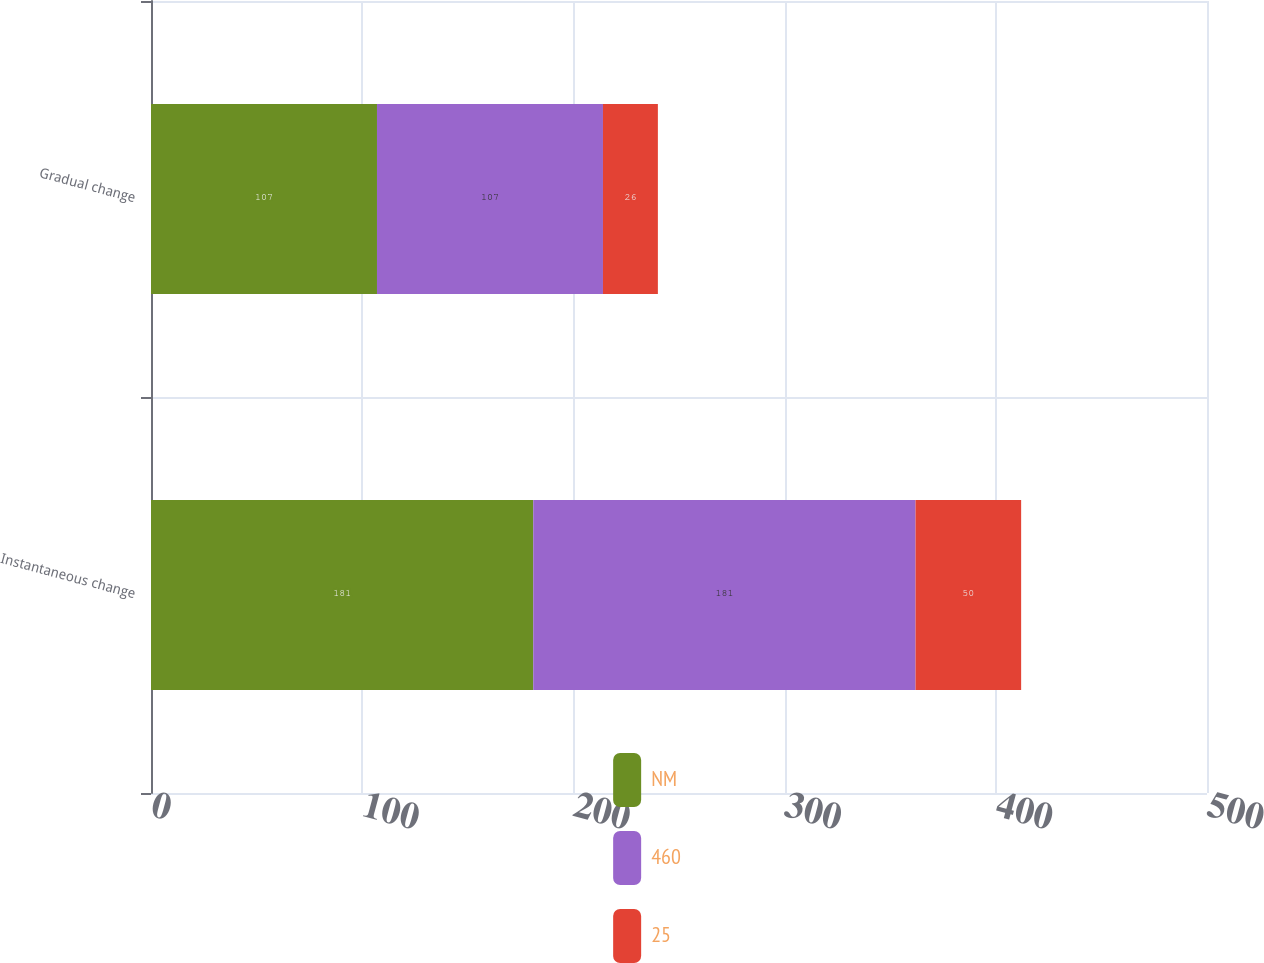Convert chart. <chart><loc_0><loc_0><loc_500><loc_500><stacked_bar_chart><ecel><fcel>Instantaneous change<fcel>Gradual change<nl><fcel>NM<fcel>181<fcel>107<nl><fcel>460<fcel>181<fcel>107<nl><fcel>25<fcel>50<fcel>26<nl></chart> 